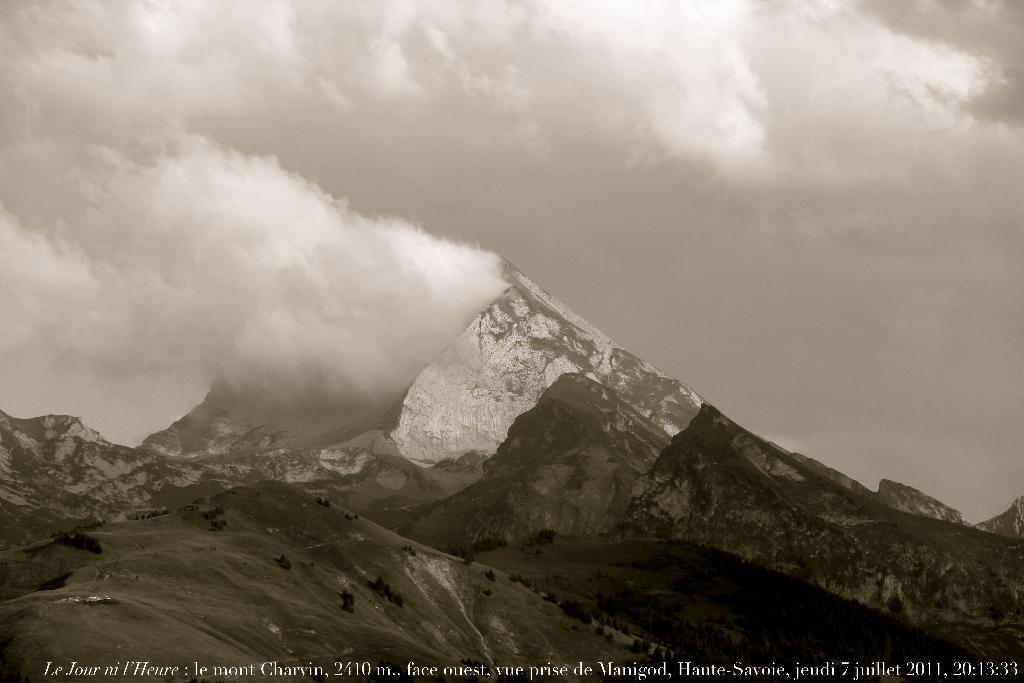What type of landscape can be seen in the image? There are hills in the image. What atmospheric condition is present in the image? There is fog in the image. What part of the natural environment is visible in the image? The sky is visible in the image. Is there any text present in the image? Yes, there is text written at the bottom of the image. Can you tell me what breed of dog is running through the wood in the image? There is no dog or wood present in the image; it features hills and fog. 